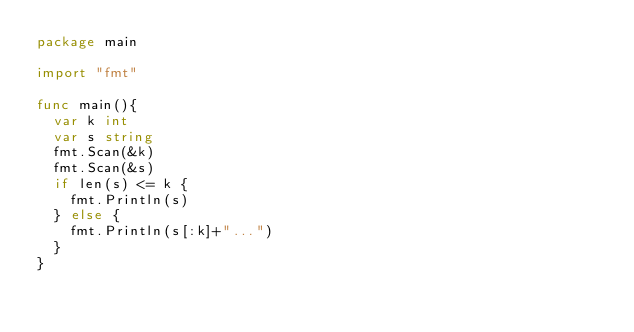<code> <loc_0><loc_0><loc_500><loc_500><_Go_>package main

import "fmt"

func main(){
	var k int
	var s string
	fmt.Scan(&k)
	fmt.Scan(&s)
	if len(s) <= k {
		fmt.Println(s)
	} else {
		fmt.Println(s[:k]+"...")
	}
}
</code> 